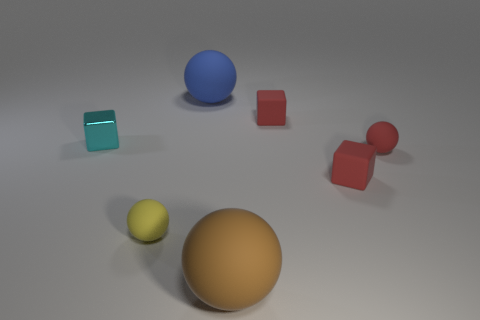Is there a tiny cyan block that has the same material as the blue sphere?
Give a very brief answer. No. What is the color of the tiny metallic object?
Ensure brevity in your answer.  Cyan. There is a matte block behind the matte ball right of the tiny matte block behind the small red matte ball; what size is it?
Your answer should be very brief. Small. What number of other things are the same shape as the yellow rubber object?
Your answer should be compact. 3. What color is the tiny thing that is both to the left of the brown matte object and to the right of the metal thing?
Your response must be concise. Yellow. Is there any other thing that has the same size as the brown thing?
Keep it short and to the point. Yes. Does the big matte sphere in front of the blue ball have the same color as the shiny thing?
Offer a very short reply. No. How many cubes are either cyan things or small yellow rubber things?
Provide a short and direct response. 1. There is a yellow object right of the small shiny block; what is its shape?
Your answer should be compact. Sphere. There is a sphere that is in front of the rubber ball that is on the left side of the large matte sphere that is on the left side of the large brown matte object; what color is it?
Give a very brief answer. Brown. 